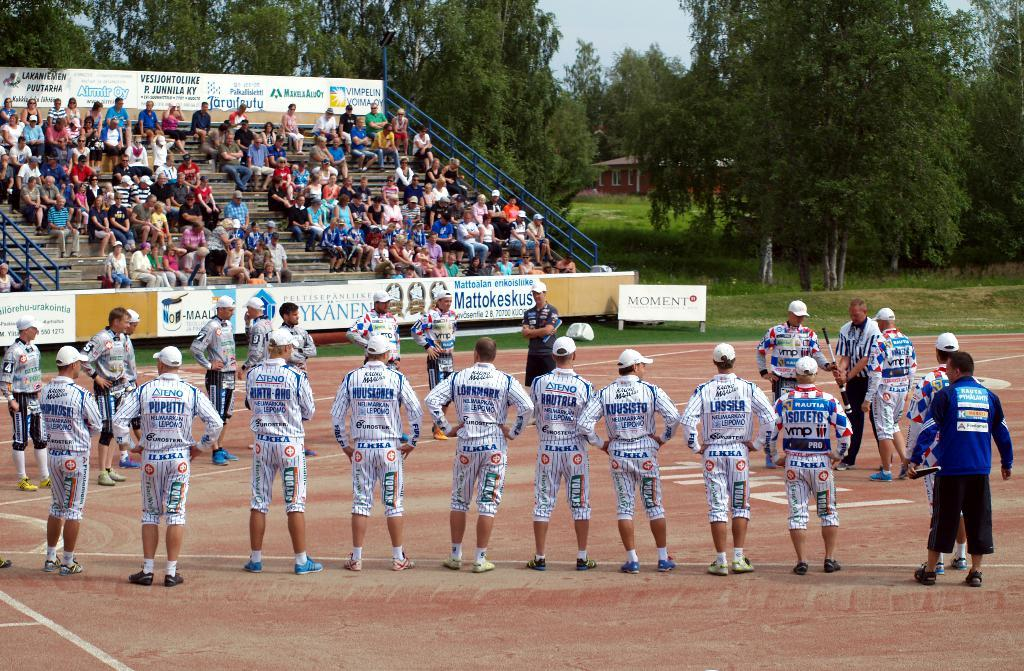<image>
Summarize the visual content of the image. Young men in uniform stand in front off a crowd in front of a Moment sign. 